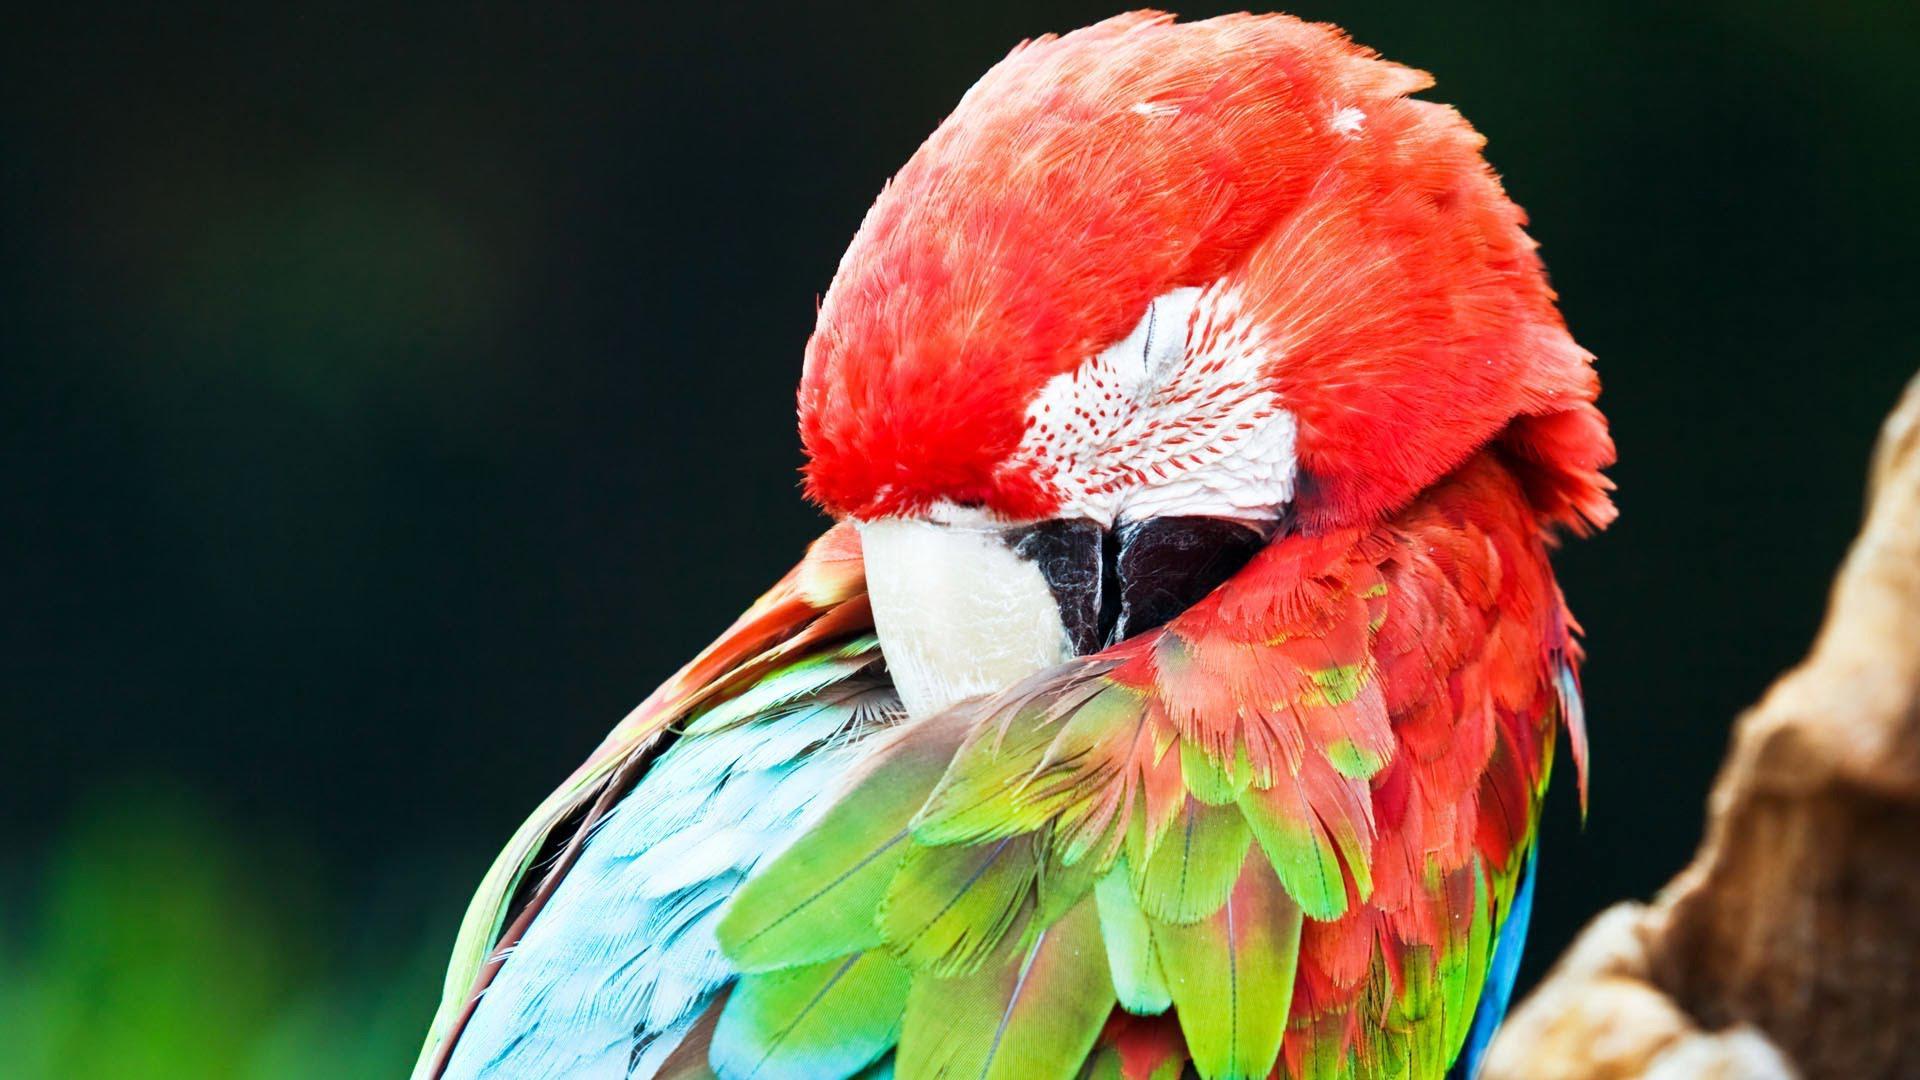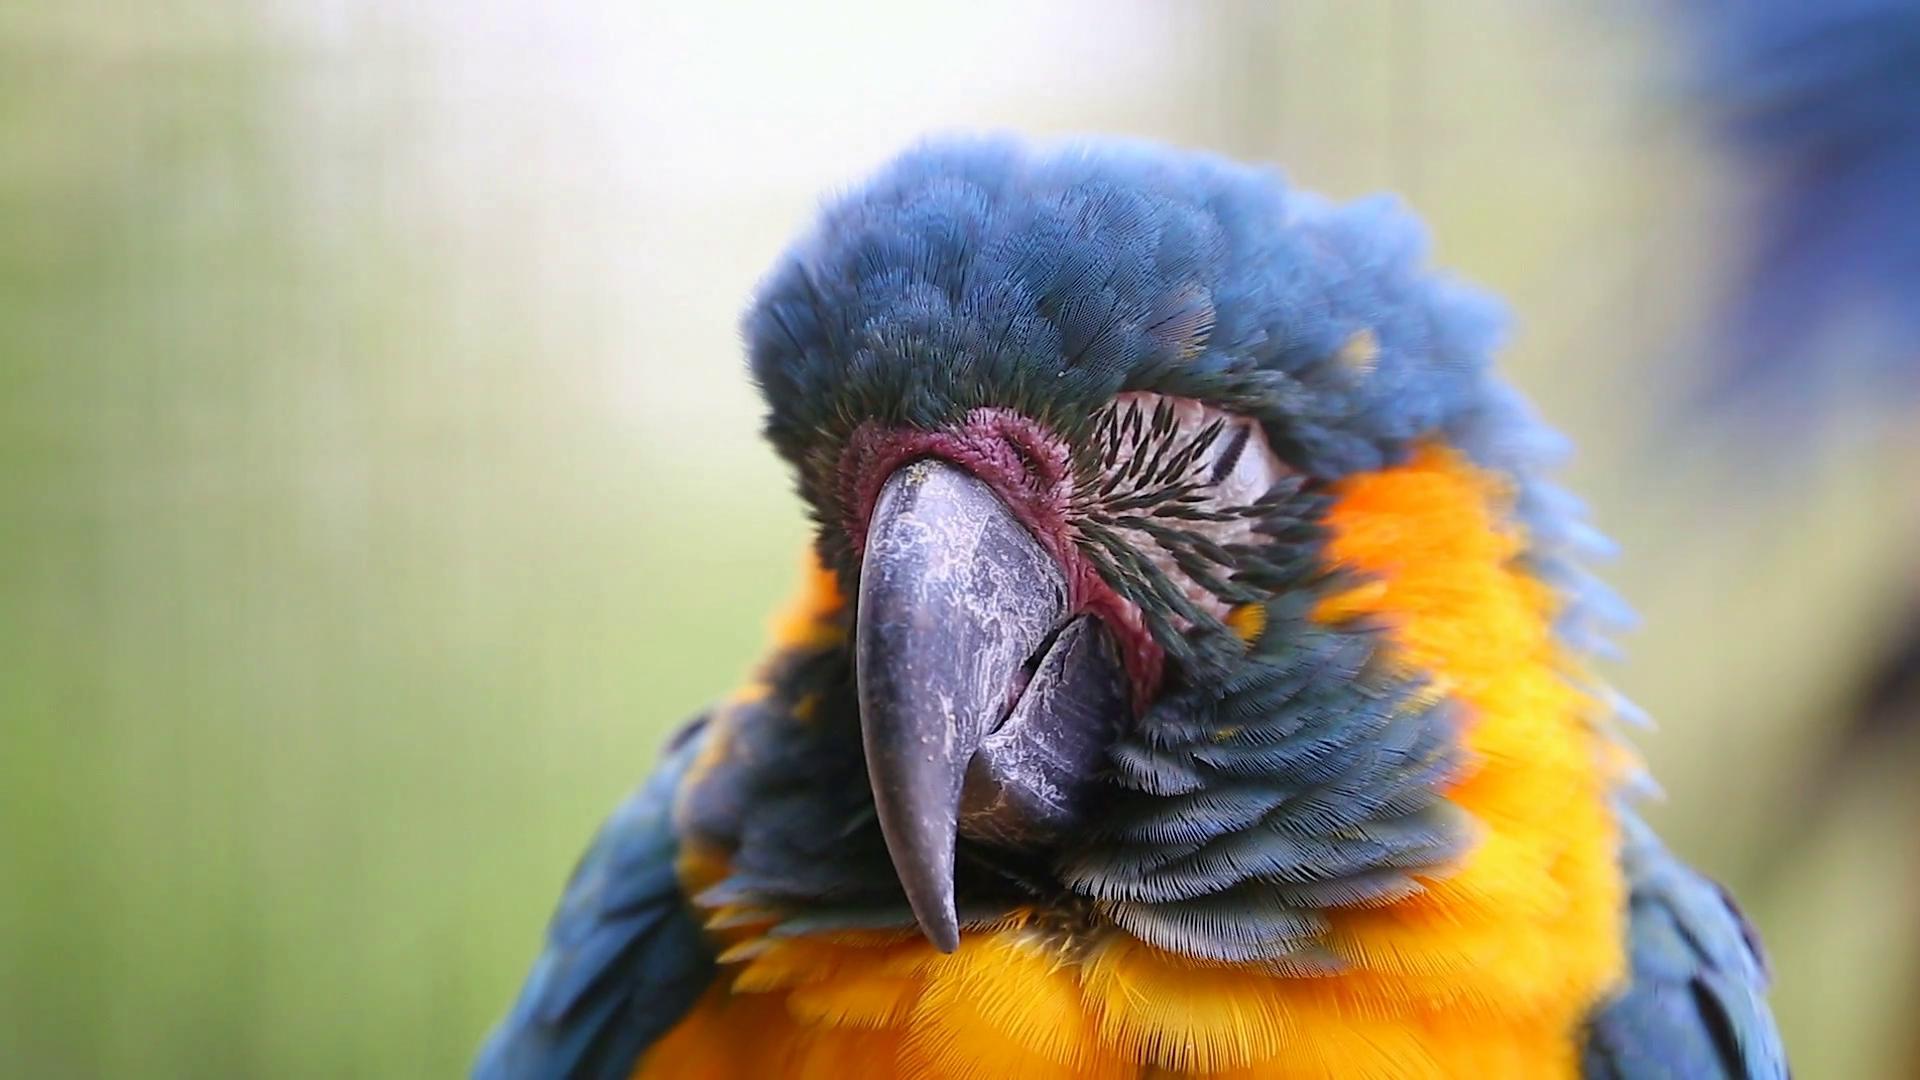The first image is the image on the left, the second image is the image on the right. Assess this claim about the two images: "All of the birds are outside.". Correct or not? Answer yes or no. Yes. The first image is the image on the left, the second image is the image on the right. Considering the images on both sides, is "Each image contains a single parrot, and each parrot has its eye squeezed tightly shut." valid? Answer yes or no. Yes. 